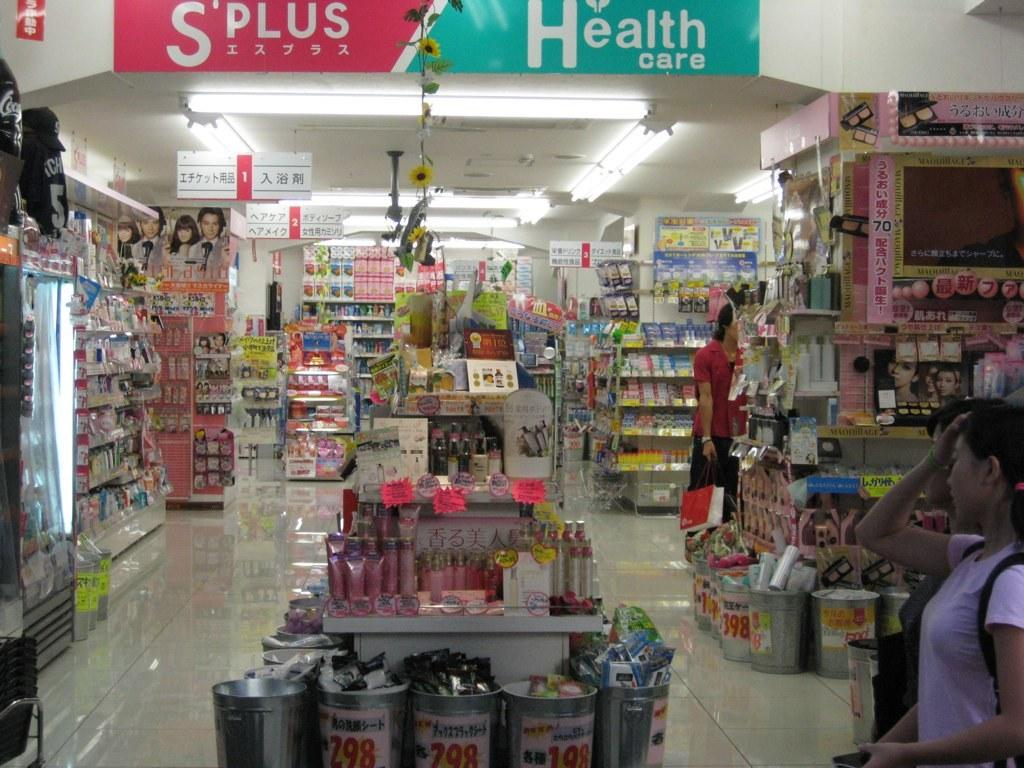Provide a one-sentence caption for the provided image. A grocery store has a green Health care banner displayed. 